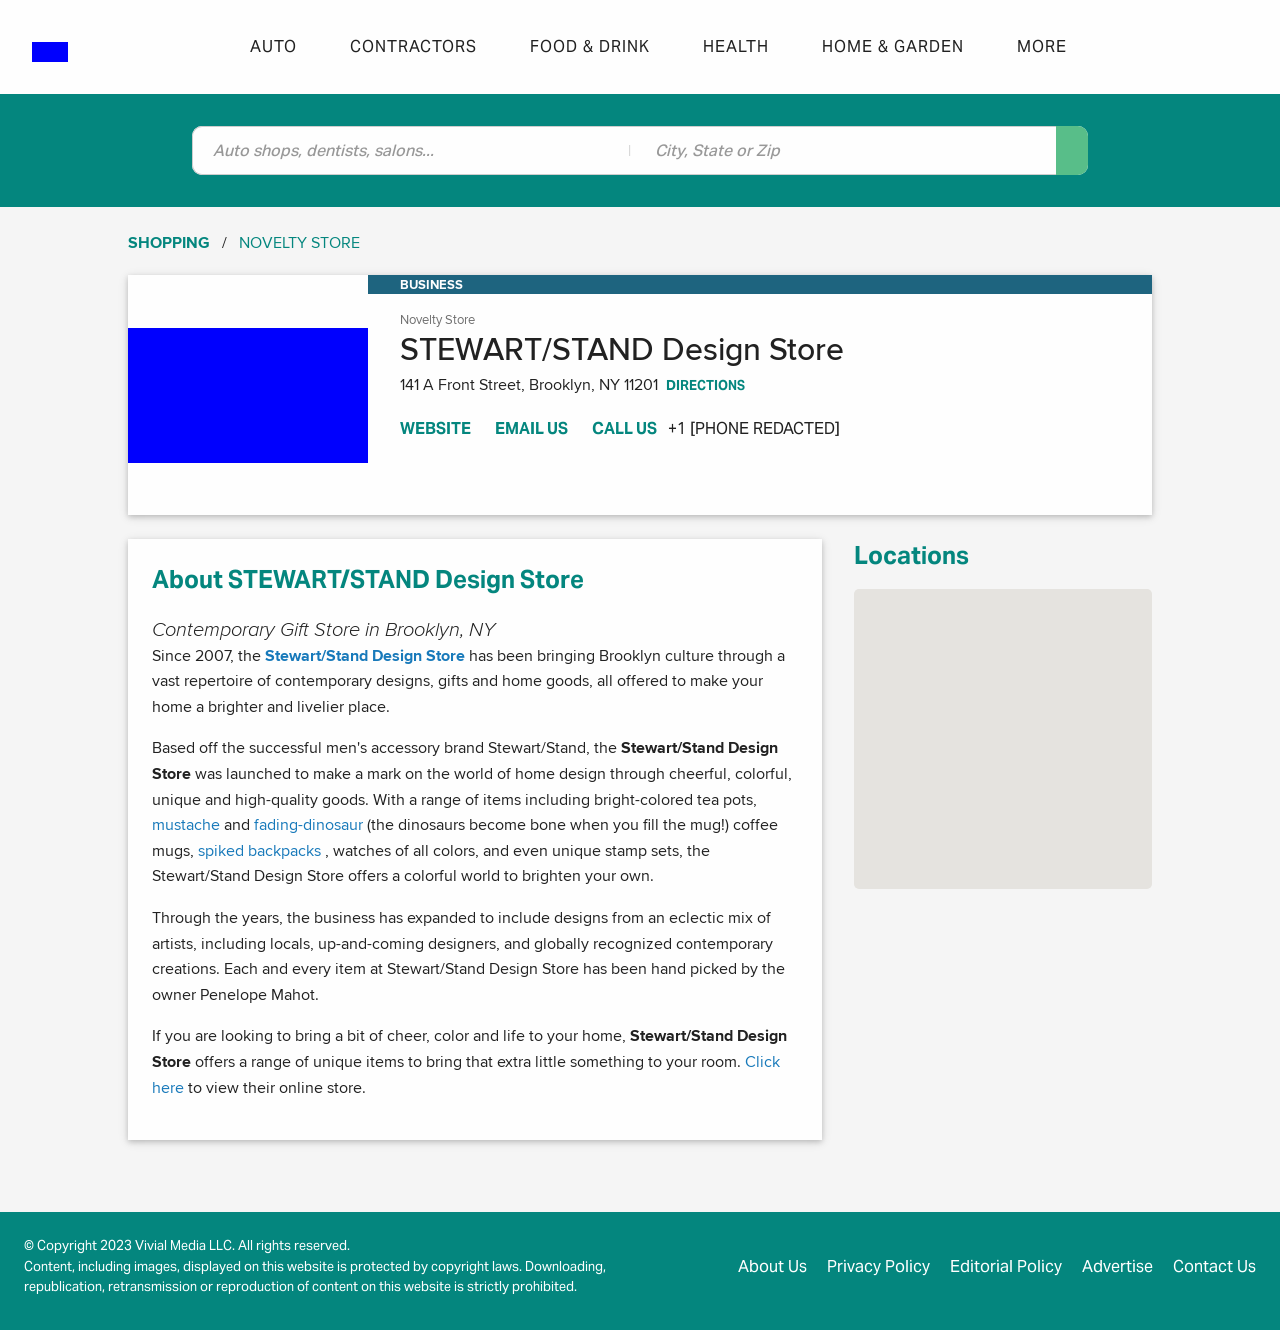Could you detail the process for assembling this website using HTML? The website for STEWART/STAND Design Store is designed to showcase a wide array of contemporary gifts and home goods. It’s structured using HTML to provide a clear and informative layout, featuring sections such as navigation bar, business information, store description, products preview, and contact information. CSS and JavaScript are used alongside HTML to enhance functionality and design, providing a user-friendly interface that encourages interaction and exploration of the store's offerings. 